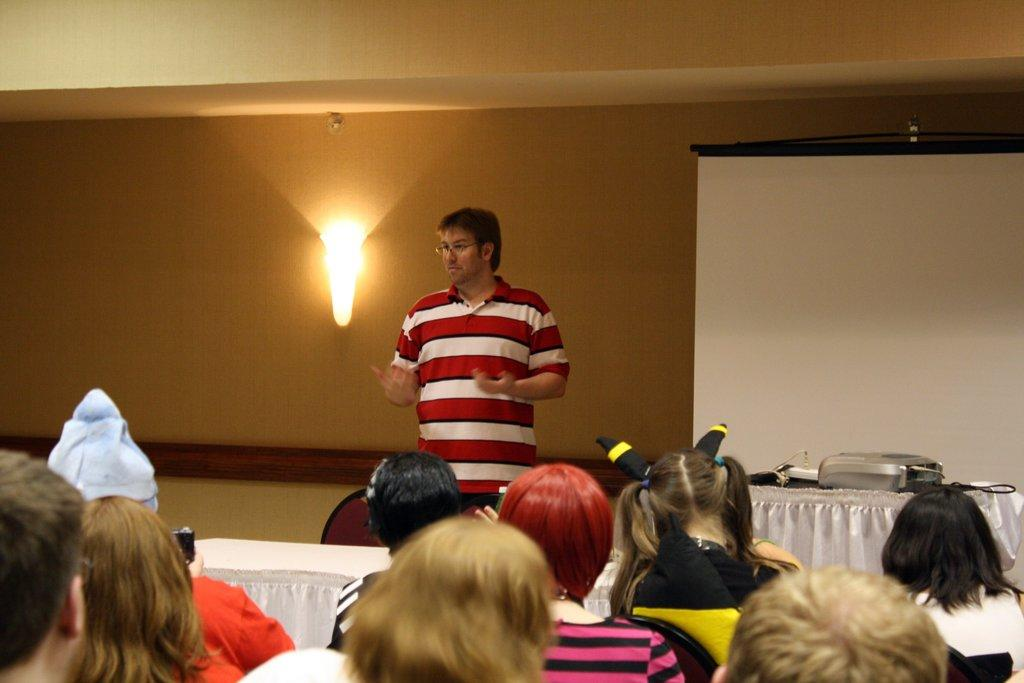What are the people in the image doing? The people in the image are sitting. What is the man in the image doing? The man in the image is standing. What furniture is present in the image? There is a table and chairs in the image. What can be seen on the table in the background? In the background, there are objects on the table. What is visible in the background of the image? There is a white banner, a wall, and a light in the background. Who is the creator of the learning materials seen in the image? There are no learning materials visible in the image. What expertise does the expert in the image have? There is no expert present in the image. 